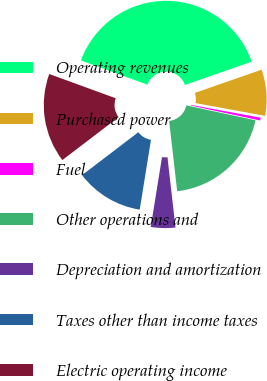Convert chart. <chart><loc_0><loc_0><loc_500><loc_500><pie_chart><fcel>Operating revenues<fcel>Purchased power<fcel>Fuel<fcel>Other operations and<fcel>Depreciation and amortization<fcel>Taxes other than income taxes<fcel>Electric operating income<nl><fcel>39.1%<fcel>8.22%<fcel>0.5%<fcel>19.8%<fcel>4.36%<fcel>12.08%<fcel>15.94%<nl></chart> 